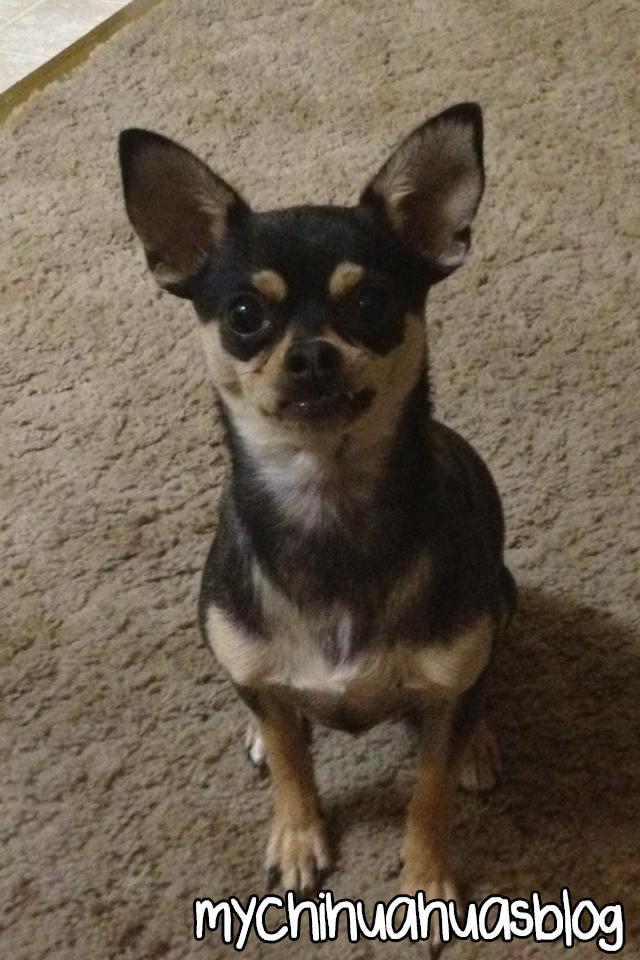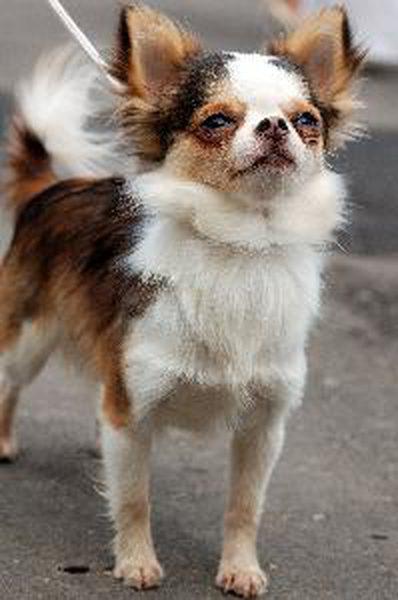The first image is the image on the left, the second image is the image on the right. Assess this claim about the two images: "At least one of the images features a single dog and shows grass in the image". Correct or not? Answer yes or no. No. The first image is the image on the left, the second image is the image on the right. For the images displayed, is the sentence "A leash extends from the small dog in the right-hand image." factually correct? Answer yes or no. Yes. 